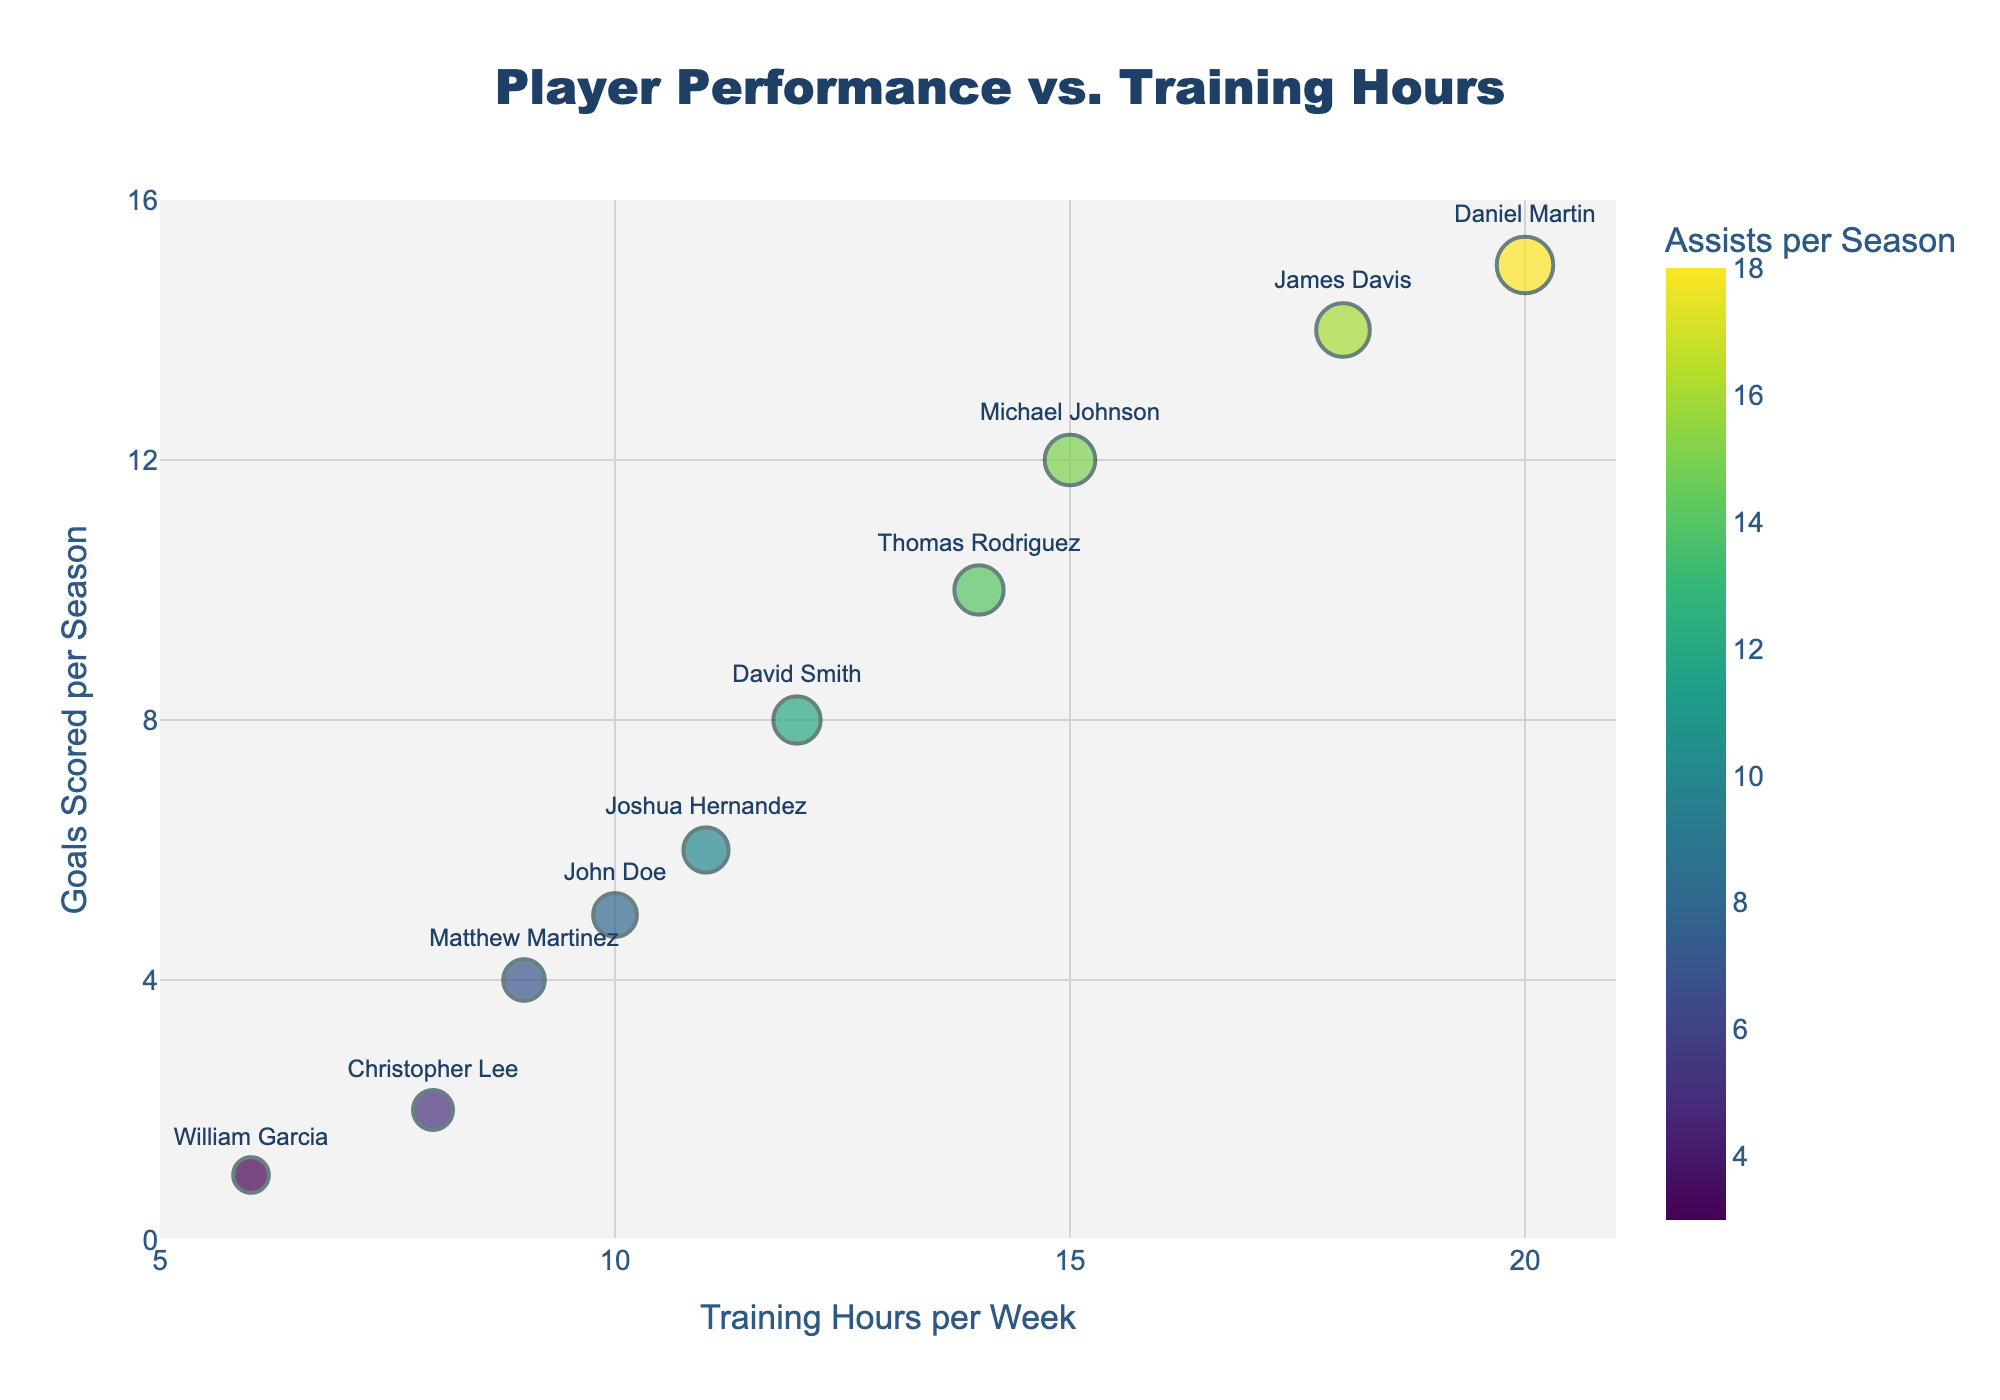How many players trained for more than 15 hours per week? We count the data points along the x-axis that are greater than 15 on the "Training Hours per Week" axis. There are two such points.
Answer: 2 What is the range of goals scored per season? We look at the y-axis values for "Goals Scored per Season" and identify the minimum and maximum values presented on the scatter plot, which are 1 and 15 respectively. Therefore, the range is 15 - 1 = 14.
Answer: 14 Which player scored the most goals in a season? By finding the highest data point on the y-axis labeled "Goals Scored per Season," we can see that Daniel Martin is at the top with 15 goals.
Answer: Daniel Martin Who has the highest number of assists per season? The color bar indicates assists per season, and the player whose marker (dot) is the darkest green color represents the player with the highest number of assists. Daniel Martin, with a darker marker, has the highest number of assists (18).
Answer: Daniel Martin What is the relationship between training hours and goals scored? Observing the scatter plot, we generally see that as the "Training Hours per Week" increases along the x-axis, the "Goals Scored per Season" plotted on the y-axis also tends to increase. While there may be some exceptions, the overall pattern indicates a positive correlation between training hours and goals scored.
Answer: Positive correlation Which player has the highest successful passes per game? By identifying the largest marker on the plot, we can see that Daniel Martin, who trained 20 hours per week, has the largest size marker indicating the highest number of successful passes per game (50).
Answer: Daniel Martin Do players with more training hours tend to have more assists? Examining the scatter plot, we notice that players with more training hours (right-side points) often have darker shades of green, indicating higher assist numbers. Thus, players with more training hours tend to have more assists.
Answer: Yes What is the average training hours per week for the players? Summing all the training hours per week (10 + 12 + 15 + 8 + 20 + 18 + 6 + 14 + 9 + 11 = 123) and dividing by the number of players (10), we get an average of 123 / 10 = 12.3.
Answer: 12.3 Compare the goals scored per season between John Doe and Michael Johnson. John Doe scored 5 goals per season, and Michael Johnson scored 12 goals per season. Comparing them, Michael Johnson scored 7 more goals than John Doe.
Answer: Michael Johnson scored 7 more goals Is there any player who has both less than 10 training hours per week and more than 10 assists per season? Looking at the data points, we look for any markers positioned left of 10 on the x-axis and darker on the color scale indicating assists. There are no such players in the given data.
Answer: No 